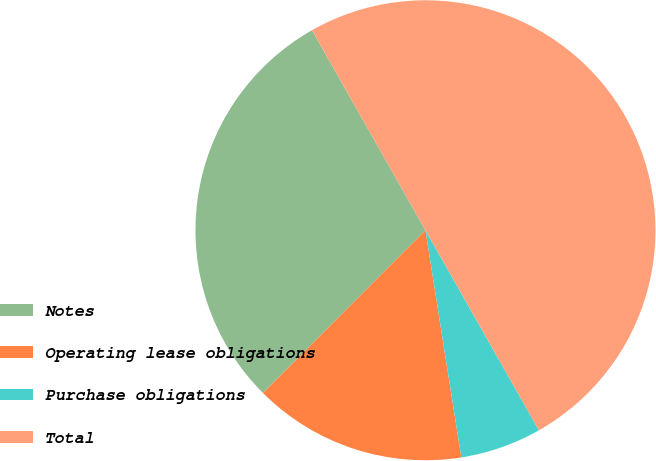<chart> <loc_0><loc_0><loc_500><loc_500><pie_chart><fcel>Notes<fcel>Operating lease obligations<fcel>Purchase obligations<fcel>Total<nl><fcel>29.3%<fcel>14.98%<fcel>5.72%<fcel>50.0%<nl></chart> 